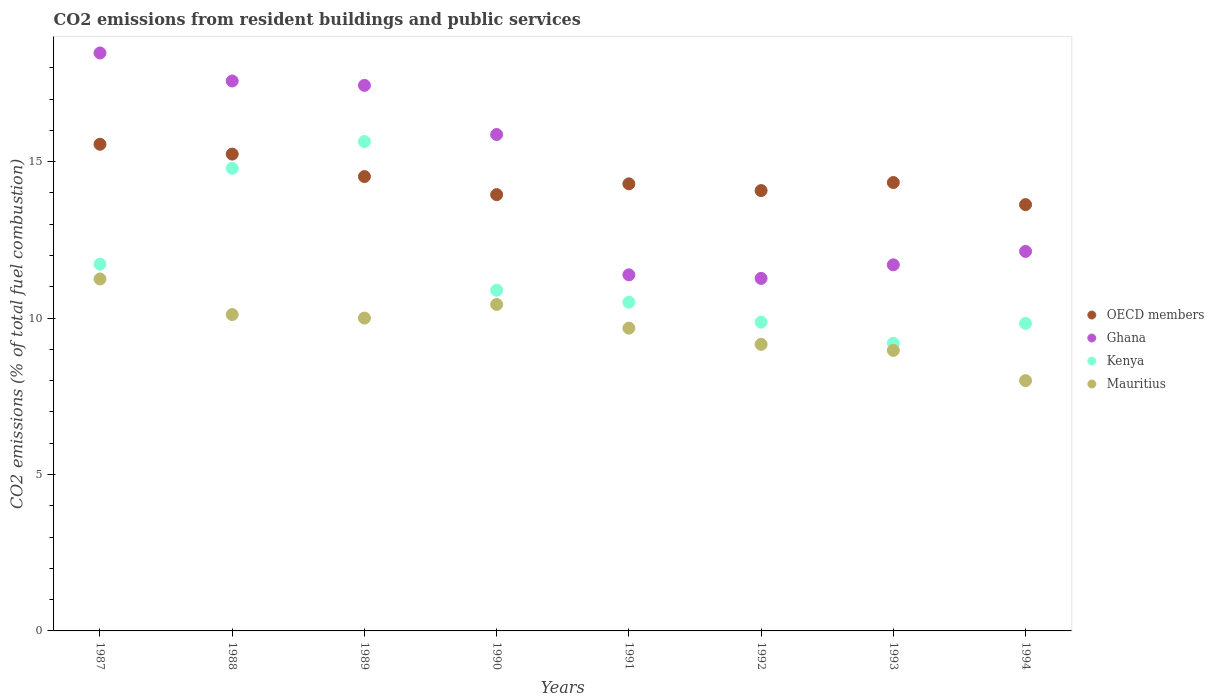How many different coloured dotlines are there?
Give a very brief answer. 4. What is the total CO2 emitted in Ghana in 1988?
Provide a succinct answer. 17.58. Across all years, what is the maximum total CO2 emitted in Mauritius?
Offer a very short reply. 11.25. Across all years, what is the minimum total CO2 emitted in Ghana?
Keep it short and to the point. 11.27. In which year was the total CO2 emitted in Ghana minimum?
Your response must be concise. 1992. What is the total total CO2 emitted in Kenya in the graph?
Offer a very short reply. 92.44. What is the difference between the total CO2 emitted in Mauritius in 1988 and that in 1990?
Your response must be concise. -0.32. What is the difference between the total CO2 emitted in OECD members in 1993 and the total CO2 emitted in Ghana in 1989?
Ensure brevity in your answer.  -3.11. What is the average total CO2 emitted in Ghana per year?
Provide a short and direct response. 14.48. In the year 1992, what is the difference between the total CO2 emitted in Kenya and total CO2 emitted in OECD members?
Provide a succinct answer. -4.21. In how many years, is the total CO2 emitted in Ghana greater than 2?
Ensure brevity in your answer.  8. What is the ratio of the total CO2 emitted in Ghana in 1987 to that in 1991?
Offer a very short reply. 1.62. Is the total CO2 emitted in Mauritius in 1989 less than that in 1992?
Your answer should be compact. No. What is the difference between the highest and the second highest total CO2 emitted in Mauritius?
Give a very brief answer. 0.82. What is the difference between the highest and the lowest total CO2 emitted in Mauritius?
Your answer should be compact. 3.25. Is the sum of the total CO2 emitted in Kenya in 1992 and 1994 greater than the maximum total CO2 emitted in Ghana across all years?
Provide a succinct answer. Yes. Is it the case that in every year, the sum of the total CO2 emitted in Kenya and total CO2 emitted in Ghana  is greater than the sum of total CO2 emitted in Mauritius and total CO2 emitted in OECD members?
Provide a short and direct response. No. Does the total CO2 emitted in OECD members monotonically increase over the years?
Provide a short and direct response. No. Is the total CO2 emitted in Kenya strictly greater than the total CO2 emitted in Mauritius over the years?
Offer a terse response. Yes. How many dotlines are there?
Your response must be concise. 4. How many years are there in the graph?
Your response must be concise. 8. Does the graph contain any zero values?
Ensure brevity in your answer.  No. Where does the legend appear in the graph?
Your answer should be very brief. Center right. How many legend labels are there?
Provide a succinct answer. 4. How are the legend labels stacked?
Provide a succinct answer. Vertical. What is the title of the graph?
Provide a short and direct response. CO2 emissions from resident buildings and public services. What is the label or title of the X-axis?
Provide a short and direct response. Years. What is the label or title of the Y-axis?
Ensure brevity in your answer.  CO2 emissions (% of total fuel combustion). What is the CO2 emissions (% of total fuel combustion) of OECD members in 1987?
Provide a short and direct response. 15.56. What is the CO2 emissions (% of total fuel combustion) in Ghana in 1987?
Offer a very short reply. 18.47. What is the CO2 emissions (% of total fuel combustion) in Kenya in 1987?
Provide a succinct answer. 11.72. What is the CO2 emissions (% of total fuel combustion) of Mauritius in 1987?
Keep it short and to the point. 11.25. What is the CO2 emissions (% of total fuel combustion) of OECD members in 1988?
Ensure brevity in your answer.  15.24. What is the CO2 emissions (% of total fuel combustion) of Ghana in 1988?
Make the answer very short. 17.58. What is the CO2 emissions (% of total fuel combustion) of Kenya in 1988?
Keep it short and to the point. 14.79. What is the CO2 emissions (% of total fuel combustion) of Mauritius in 1988?
Your answer should be compact. 10.11. What is the CO2 emissions (% of total fuel combustion) in OECD members in 1989?
Offer a very short reply. 14.52. What is the CO2 emissions (% of total fuel combustion) in Ghana in 1989?
Your response must be concise. 17.44. What is the CO2 emissions (% of total fuel combustion) of Kenya in 1989?
Your answer should be very brief. 15.64. What is the CO2 emissions (% of total fuel combustion) in OECD members in 1990?
Offer a terse response. 13.95. What is the CO2 emissions (% of total fuel combustion) of Ghana in 1990?
Ensure brevity in your answer.  15.87. What is the CO2 emissions (% of total fuel combustion) of Kenya in 1990?
Offer a very short reply. 10.89. What is the CO2 emissions (% of total fuel combustion) in Mauritius in 1990?
Your answer should be compact. 10.43. What is the CO2 emissions (% of total fuel combustion) in OECD members in 1991?
Keep it short and to the point. 14.29. What is the CO2 emissions (% of total fuel combustion) in Ghana in 1991?
Provide a succinct answer. 11.38. What is the CO2 emissions (% of total fuel combustion) in Kenya in 1991?
Your answer should be compact. 10.51. What is the CO2 emissions (% of total fuel combustion) of Mauritius in 1991?
Your answer should be very brief. 9.68. What is the CO2 emissions (% of total fuel combustion) of OECD members in 1992?
Give a very brief answer. 14.07. What is the CO2 emissions (% of total fuel combustion) of Ghana in 1992?
Your answer should be compact. 11.27. What is the CO2 emissions (% of total fuel combustion) of Kenya in 1992?
Give a very brief answer. 9.87. What is the CO2 emissions (% of total fuel combustion) in Mauritius in 1992?
Keep it short and to the point. 9.16. What is the CO2 emissions (% of total fuel combustion) of OECD members in 1993?
Your answer should be compact. 14.33. What is the CO2 emissions (% of total fuel combustion) in Ghana in 1993?
Provide a short and direct response. 11.7. What is the CO2 emissions (% of total fuel combustion) in Kenya in 1993?
Make the answer very short. 9.19. What is the CO2 emissions (% of total fuel combustion) in Mauritius in 1993?
Make the answer very short. 8.97. What is the CO2 emissions (% of total fuel combustion) of OECD members in 1994?
Your answer should be compact. 13.63. What is the CO2 emissions (% of total fuel combustion) in Ghana in 1994?
Your answer should be very brief. 12.13. What is the CO2 emissions (% of total fuel combustion) in Kenya in 1994?
Give a very brief answer. 9.83. What is the CO2 emissions (% of total fuel combustion) of Mauritius in 1994?
Your answer should be compact. 8. Across all years, what is the maximum CO2 emissions (% of total fuel combustion) of OECD members?
Give a very brief answer. 15.56. Across all years, what is the maximum CO2 emissions (% of total fuel combustion) in Ghana?
Your answer should be compact. 18.47. Across all years, what is the maximum CO2 emissions (% of total fuel combustion) in Kenya?
Your response must be concise. 15.64. Across all years, what is the maximum CO2 emissions (% of total fuel combustion) of Mauritius?
Your answer should be compact. 11.25. Across all years, what is the minimum CO2 emissions (% of total fuel combustion) of OECD members?
Provide a succinct answer. 13.63. Across all years, what is the minimum CO2 emissions (% of total fuel combustion) in Ghana?
Make the answer very short. 11.27. Across all years, what is the minimum CO2 emissions (% of total fuel combustion) in Kenya?
Give a very brief answer. 9.19. What is the total CO2 emissions (% of total fuel combustion) of OECD members in the graph?
Give a very brief answer. 115.59. What is the total CO2 emissions (% of total fuel combustion) in Ghana in the graph?
Your response must be concise. 115.84. What is the total CO2 emissions (% of total fuel combustion) of Kenya in the graph?
Provide a succinct answer. 92.44. What is the total CO2 emissions (% of total fuel combustion) of Mauritius in the graph?
Your response must be concise. 77.6. What is the difference between the CO2 emissions (% of total fuel combustion) of OECD members in 1987 and that in 1988?
Ensure brevity in your answer.  0.31. What is the difference between the CO2 emissions (% of total fuel combustion) in Ghana in 1987 and that in 1988?
Your answer should be very brief. 0.9. What is the difference between the CO2 emissions (% of total fuel combustion) in Kenya in 1987 and that in 1988?
Offer a terse response. -3.07. What is the difference between the CO2 emissions (% of total fuel combustion) in Mauritius in 1987 and that in 1988?
Make the answer very short. 1.14. What is the difference between the CO2 emissions (% of total fuel combustion) in OECD members in 1987 and that in 1989?
Give a very brief answer. 1.03. What is the difference between the CO2 emissions (% of total fuel combustion) of Ghana in 1987 and that in 1989?
Offer a very short reply. 1.04. What is the difference between the CO2 emissions (% of total fuel combustion) in Kenya in 1987 and that in 1989?
Give a very brief answer. -3.92. What is the difference between the CO2 emissions (% of total fuel combustion) in OECD members in 1987 and that in 1990?
Offer a very short reply. 1.61. What is the difference between the CO2 emissions (% of total fuel combustion) in Ghana in 1987 and that in 1990?
Provide a succinct answer. 2.61. What is the difference between the CO2 emissions (% of total fuel combustion) in Kenya in 1987 and that in 1990?
Provide a succinct answer. 0.83. What is the difference between the CO2 emissions (% of total fuel combustion) in Mauritius in 1987 and that in 1990?
Offer a terse response. 0.82. What is the difference between the CO2 emissions (% of total fuel combustion) of OECD members in 1987 and that in 1991?
Give a very brief answer. 1.26. What is the difference between the CO2 emissions (% of total fuel combustion) of Ghana in 1987 and that in 1991?
Your answer should be very brief. 7.09. What is the difference between the CO2 emissions (% of total fuel combustion) in Kenya in 1987 and that in 1991?
Offer a terse response. 1.22. What is the difference between the CO2 emissions (% of total fuel combustion) of Mauritius in 1987 and that in 1991?
Your answer should be compact. 1.57. What is the difference between the CO2 emissions (% of total fuel combustion) of OECD members in 1987 and that in 1992?
Offer a terse response. 1.48. What is the difference between the CO2 emissions (% of total fuel combustion) in Ghana in 1987 and that in 1992?
Give a very brief answer. 7.21. What is the difference between the CO2 emissions (% of total fuel combustion) of Kenya in 1987 and that in 1992?
Ensure brevity in your answer.  1.85. What is the difference between the CO2 emissions (% of total fuel combustion) in Mauritius in 1987 and that in 1992?
Offer a terse response. 2.09. What is the difference between the CO2 emissions (% of total fuel combustion) in OECD members in 1987 and that in 1993?
Provide a succinct answer. 1.22. What is the difference between the CO2 emissions (% of total fuel combustion) of Ghana in 1987 and that in 1993?
Give a very brief answer. 6.77. What is the difference between the CO2 emissions (% of total fuel combustion) of Kenya in 1987 and that in 1993?
Offer a terse response. 2.53. What is the difference between the CO2 emissions (% of total fuel combustion) of Mauritius in 1987 and that in 1993?
Make the answer very short. 2.28. What is the difference between the CO2 emissions (% of total fuel combustion) of OECD members in 1987 and that in 1994?
Offer a very short reply. 1.93. What is the difference between the CO2 emissions (% of total fuel combustion) in Ghana in 1987 and that in 1994?
Your answer should be compact. 6.34. What is the difference between the CO2 emissions (% of total fuel combustion) of Kenya in 1987 and that in 1994?
Ensure brevity in your answer.  1.89. What is the difference between the CO2 emissions (% of total fuel combustion) of Mauritius in 1987 and that in 1994?
Keep it short and to the point. 3.25. What is the difference between the CO2 emissions (% of total fuel combustion) of OECD members in 1988 and that in 1989?
Your answer should be very brief. 0.72. What is the difference between the CO2 emissions (% of total fuel combustion) in Ghana in 1988 and that in 1989?
Give a very brief answer. 0.14. What is the difference between the CO2 emissions (% of total fuel combustion) in Kenya in 1988 and that in 1989?
Your response must be concise. -0.85. What is the difference between the CO2 emissions (% of total fuel combustion) in Mauritius in 1988 and that in 1989?
Offer a very short reply. 0.11. What is the difference between the CO2 emissions (% of total fuel combustion) in OECD members in 1988 and that in 1990?
Give a very brief answer. 1.3. What is the difference between the CO2 emissions (% of total fuel combustion) in Ghana in 1988 and that in 1990?
Ensure brevity in your answer.  1.71. What is the difference between the CO2 emissions (% of total fuel combustion) of Kenya in 1988 and that in 1990?
Provide a short and direct response. 3.9. What is the difference between the CO2 emissions (% of total fuel combustion) in Mauritius in 1988 and that in 1990?
Your response must be concise. -0.32. What is the difference between the CO2 emissions (% of total fuel combustion) of OECD members in 1988 and that in 1991?
Your answer should be compact. 0.95. What is the difference between the CO2 emissions (% of total fuel combustion) in Ghana in 1988 and that in 1991?
Ensure brevity in your answer.  6.2. What is the difference between the CO2 emissions (% of total fuel combustion) in Kenya in 1988 and that in 1991?
Your response must be concise. 4.28. What is the difference between the CO2 emissions (% of total fuel combustion) in Mauritius in 1988 and that in 1991?
Offer a terse response. 0.43. What is the difference between the CO2 emissions (% of total fuel combustion) of OECD members in 1988 and that in 1992?
Give a very brief answer. 1.17. What is the difference between the CO2 emissions (% of total fuel combustion) in Ghana in 1988 and that in 1992?
Offer a very short reply. 6.31. What is the difference between the CO2 emissions (% of total fuel combustion) of Kenya in 1988 and that in 1992?
Make the answer very short. 4.92. What is the difference between the CO2 emissions (% of total fuel combustion) in Mauritius in 1988 and that in 1992?
Ensure brevity in your answer.  0.95. What is the difference between the CO2 emissions (% of total fuel combustion) in OECD members in 1988 and that in 1993?
Provide a short and direct response. 0.91. What is the difference between the CO2 emissions (% of total fuel combustion) in Ghana in 1988 and that in 1993?
Offer a terse response. 5.88. What is the difference between the CO2 emissions (% of total fuel combustion) of Kenya in 1988 and that in 1993?
Give a very brief answer. 5.59. What is the difference between the CO2 emissions (% of total fuel combustion) of Mauritius in 1988 and that in 1993?
Your answer should be very brief. 1.15. What is the difference between the CO2 emissions (% of total fuel combustion) of OECD members in 1988 and that in 1994?
Your answer should be compact. 1.62. What is the difference between the CO2 emissions (% of total fuel combustion) of Ghana in 1988 and that in 1994?
Keep it short and to the point. 5.45. What is the difference between the CO2 emissions (% of total fuel combustion) of Kenya in 1988 and that in 1994?
Your response must be concise. 4.96. What is the difference between the CO2 emissions (% of total fuel combustion) of Mauritius in 1988 and that in 1994?
Ensure brevity in your answer.  2.11. What is the difference between the CO2 emissions (% of total fuel combustion) in OECD members in 1989 and that in 1990?
Your response must be concise. 0.58. What is the difference between the CO2 emissions (% of total fuel combustion) in Ghana in 1989 and that in 1990?
Your answer should be compact. 1.57. What is the difference between the CO2 emissions (% of total fuel combustion) in Kenya in 1989 and that in 1990?
Keep it short and to the point. 4.75. What is the difference between the CO2 emissions (% of total fuel combustion) in Mauritius in 1989 and that in 1990?
Keep it short and to the point. -0.43. What is the difference between the CO2 emissions (% of total fuel combustion) of OECD members in 1989 and that in 1991?
Offer a very short reply. 0.23. What is the difference between the CO2 emissions (% of total fuel combustion) in Ghana in 1989 and that in 1991?
Offer a terse response. 6.06. What is the difference between the CO2 emissions (% of total fuel combustion) in Kenya in 1989 and that in 1991?
Ensure brevity in your answer.  5.13. What is the difference between the CO2 emissions (% of total fuel combustion) of Mauritius in 1989 and that in 1991?
Provide a short and direct response. 0.32. What is the difference between the CO2 emissions (% of total fuel combustion) in OECD members in 1989 and that in 1992?
Provide a short and direct response. 0.45. What is the difference between the CO2 emissions (% of total fuel combustion) in Ghana in 1989 and that in 1992?
Make the answer very short. 6.17. What is the difference between the CO2 emissions (% of total fuel combustion) of Kenya in 1989 and that in 1992?
Give a very brief answer. 5.77. What is the difference between the CO2 emissions (% of total fuel combustion) in Mauritius in 1989 and that in 1992?
Ensure brevity in your answer.  0.84. What is the difference between the CO2 emissions (% of total fuel combustion) in OECD members in 1989 and that in 1993?
Offer a terse response. 0.19. What is the difference between the CO2 emissions (% of total fuel combustion) in Ghana in 1989 and that in 1993?
Provide a succinct answer. 5.74. What is the difference between the CO2 emissions (% of total fuel combustion) of Kenya in 1989 and that in 1993?
Your answer should be compact. 6.45. What is the difference between the CO2 emissions (% of total fuel combustion) in Mauritius in 1989 and that in 1993?
Ensure brevity in your answer.  1.03. What is the difference between the CO2 emissions (% of total fuel combustion) of OECD members in 1989 and that in 1994?
Ensure brevity in your answer.  0.9. What is the difference between the CO2 emissions (% of total fuel combustion) in Ghana in 1989 and that in 1994?
Your response must be concise. 5.31. What is the difference between the CO2 emissions (% of total fuel combustion) in Kenya in 1989 and that in 1994?
Provide a short and direct response. 5.81. What is the difference between the CO2 emissions (% of total fuel combustion) in OECD members in 1990 and that in 1991?
Your answer should be compact. -0.35. What is the difference between the CO2 emissions (% of total fuel combustion) of Ghana in 1990 and that in 1991?
Your answer should be compact. 4.49. What is the difference between the CO2 emissions (% of total fuel combustion) in Kenya in 1990 and that in 1991?
Make the answer very short. 0.38. What is the difference between the CO2 emissions (% of total fuel combustion) of Mauritius in 1990 and that in 1991?
Ensure brevity in your answer.  0.76. What is the difference between the CO2 emissions (% of total fuel combustion) in OECD members in 1990 and that in 1992?
Provide a short and direct response. -0.13. What is the difference between the CO2 emissions (% of total fuel combustion) of Ghana in 1990 and that in 1992?
Offer a terse response. 4.6. What is the difference between the CO2 emissions (% of total fuel combustion) in Kenya in 1990 and that in 1992?
Offer a terse response. 1.02. What is the difference between the CO2 emissions (% of total fuel combustion) of Mauritius in 1990 and that in 1992?
Provide a short and direct response. 1.27. What is the difference between the CO2 emissions (% of total fuel combustion) in OECD members in 1990 and that in 1993?
Keep it short and to the point. -0.39. What is the difference between the CO2 emissions (% of total fuel combustion) of Ghana in 1990 and that in 1993?
Make the answer very short. 4.17. What is the difference between the CO2 emissions (% of total fuel combustion) of Kenya in 1990 and that in 1993?
Ensure brevity in your answer.  1.7. What is the difference between the CO2 emissions (% of total fuel combustion) of Mauritius in 1990 and that in 1993?
Ensure brevity in your answer.  1.47. What is the difference between the CO2 emissions (% of total fuel combustion) in OECD members in 1990 and that in 1994?
Make the answer very short. 0.32. What is the difference between the CO2 emissions (% of total fuel combustion) in Ghana in 1990 and that in 1994?
Provide a short and direct response. 3.74. What is the difference between the CO2 emissions (% of total fuel combustion) of Kenya in 1990 and that in 1994?
Keep it short and to the point. 1.06. What is the difference between the CO2 emissions (% of total fuel combustion) in Mauritius in 1990 and that in 1994?
Your answer should be compact. 2.43. What is the difference between the CO2 emissions (% of total fuel combustion) of OECD members in 1991 and that in 1992?
Ensure brevity in your answer.  0.22. What is the difference between the CO2 emissions (% of total fuel combustion) in Ghana in 1991 and that in 1992?
Offer a very short reply. 0.11. What is the difference between the CO2 emissions (% of total fuel combustion) in Kenya in 1991 and that in 1992?
Provide a short and direct response. 0.64. What is the difference between the CO2 emissions (% of total fuel combustion) of Mauritius in 1991 and that in 1992?
Keep it short and to the point. 0.52. What is the difference between the CO2 emissions (% of total fuel combustion) of OECD members in 1991 and that in 1993?
Offer a terse response. -0.04. What is the difference between the CO2 emissions (% of total fuel combustion) in Ghana in 1991 and that in 1993?
Offer a very short reply. -0.32. What is the difference between the CO2 emissions (% of total fuel combustion) of Kenya in 1991 and that in 1993?
Provide a short and direct response. 1.31. What is the difference between the CO2 emissions (% of total fuel combustion) in Mauritius in 1991 and that in 1993?
Make the answer very short. 0.71. What is the difference between the CO2 emissions (% of total fuel combustion) in OECD members in 1991 and that in 1994?
Keep it short and to the point. 0.66. What is the difference between the CO2 emissions (% of total fuel combustion) of Ghana in 1991 and that in 1994?
Ensure brevity in your answer.  -0.75. What is the difference between the CO2 emissions (% of total fuel combustion) in Kenya in 1991 and that in 1994?
Make the answer very short. 0.68. What is the difference between the CO2 emissions (% of total fuel combustion) of Mauritius in 1991 and that in 1994?
Offer a terse response. 1.68. What is the difference between the CO2 emissions (% of total fuel combustion) in OECD members in 1992 and that in 1993?
Your answer should be very brief. -0.26. What is the difference between the CO2 emissions (% of total fuel combustion) in Ghana in 1992 and that in 1993?
Ensure brevity in your answer.  -0.43. What is the difference between the CO2 emissions (% of total fuel combustion) of Kenya in 1992 and that in 1993?
Provide a short and direct response. 0.68. What is the difference between the CO2 emissions (% of total fuel combustion) of Mauritius in 1992 and that in 1993?
Offer a very short reply. 0.19. What is the difference between the CO2 emissions (% of total fuel combustion) in OECD members in 1992 and that in 1994?
Your response must be concise. 0.45. What is the difference between the CO2 emissions (% of total fuel combustion) of Ghana in 1992 and that in 1994?
Offer a terse response. -0.86. What is the difference between the CO2 emissions (% of total fuel combustion) of Kenya in 1992 and that in 1994?
Provide a short and direct response. 0.04. What is the difference between the CO2 emissions (% of total fuel combustion) in Mauritius in 1992 and that in 1994?
Your response must be concise. 1.16. What is the difference between the CO2 emissions (% of total fuel combustion) of OECD members in 1993 and that in 1994?
Your response must be concise. 0.71. What is the difference between the CO2 emissions (% of total fuel combustion) of Ghana in 1993 and that in 1994?
Your answer should be very brief. -0.43. What is the difference between the CO2 emissions (% of total fuel combustion) of Kenya in 1993 and that in 1994?
Your answer should be very brief. -0.64. What is the difference between the CO2 emissions (% of total fuel combustion) of Mauritius in 1993 and that in 1994?
Offer a terse response. 0.97. What is the difference between the CO2 emissions (% of total fuel combustion) of OECD members in 1987 and the CO2 emissions (% of total fuel combustion) of Ghana in 1988?
Keep it short and to the point. -2.02. What is the difference between the CO2 emissions (% of total fuel combustion) of OECD members in 1987 and the CO2 emissions (% of total fuel combustion) of Kenya in 1988?
Make the answer very short. 0.77. What is the difference between the CO2 emissions (% of total fuel combustion) in OECD members in 1987 and the CO2 emissions (% of total fuel combustion) in Mauritius in 1988?
Provide a short and direct response. 5.44. What is the difference between the CO2 emissions (% of total fuel combustion) in Ghana in 1987 and the CO2 emissions (% of total fuel combustion) in Kenya in 1988?
Provide a succinct answer. 3.69. What is the difference between the CO2 emissions (% of total fuel combustion) of Ghana in 1987 and the CO2 emissions (% of total fuel combustion) of Mauritius in 1988?
Keep it short and to the point. 8.36. What is the difference between the CO2 emissions (% of total fuel combustion) in Kenya in 1987 and the CO2 emissions (% of total fuel combustion) in Mauritius in 1988?
Offer a terse response. 1.61. What is the difference between the CO2 emissions (% of total fuel combustion) in OECD members in 1987 and the CO2 emissions (% of total fuel combustion) in Ghana in 1989?
Make the answer very short. -1.88. What is the difference between the CO2 emissions (% of total fuel combustion) of OECD members in 1987 and the CO2 emissions (% of total fuel combustion) of Kenya in 1989?
Keep it short and to the point. -0.09. What is the difference between the CO2 emissions (% of total fuel combustion) of OECD members in 1987 and the CO2 emissions (% of total fuel combustion) of Mauritius in 1989?
Provide a succinct answer. 5.56. What is the difference between the CO2 emissions (% of total fuel combustion) in Ghana in 1987 and the CO2 emissions (% of total fuel combustion) in Kenya in 1989?
Keep it short and to the point. 2.83. What is the difference between the CO2 emissions (% of total fuel combustion) of Ghana in 1987 and the CO2 emissions (% of total fuel combustion) of Mauritius in 1989?
Your answer should be very brief. 8.47. What is the difference between the CO2 emissions (% of total fuel combustion) of Kenya in 1987 and the CO2 emissions (% of total fuel combustion) of Mauritius in 1989?
Offer a very short reply. 1.72. What is the difference between the CO2 emissions (% of total fuel combustion) in OECD members in 1987 and the CO2 emissions (% of total fuel combustion) in Ghana in 1990?
Give a very brief answer. -0.31. What is the difference between the CO2 emissions (% of total fuel combustion) in OECD members in 1987 and the CO2 emissions (% of total fuel combustion) in Kenya in 1990?
Give a very brief answer. 4.67. What is the difference between the CO2 emissions (% of total fuel combustion) in OECD members in 1987 and the CO2 emissions (% of total fuel combustion) in Mauritius in 1990?
Give a very brief answer. 5.12. What is the difference between the CO2 emissions (% of total fuel combustion) of Ghana in 1987 and the CO2 emissions (% of total fuel combustion) of Kenya in 1990?
Give a very brief answer. 7.58. What is the difference between the CO2 emissions (% of total fuel combustion) in Ghana in 1987 and the CO2 emissions (% of total fuel combustion) in Mauritius in 1990?
Make the answer very short. 8.04. What is the difference between the CO2 emissions (% of total fuel combustion) of Kenya in 1987 and the CO2 emissions (% of total fuel combustion) of Mauritius in 1990?
Your response must be concise. 1.29. What is the difference between the CO2 emissions (% of total fuel combustion) of OECD members in 1987 and the CO2 emissions (% of total fuel combustion) of Ghana in 1991?
Offer a terse response. 4.17. What is the difference between the CO2 emissions (% of total fuel combustion) of OECD members in 1987 and the CO2 emissions (% of total fuel combustion) of Kenya in 1991?
Your response must be concise. 5.05. What is the difference between the CO2 emissions (% of total fuel combustion) of OECD members in 1987 and the CO2 emissions (% of total fuel combustion) of Mauritius in 1991?
Ensure brevity in your answer.  5.88. What is the difference between the CO2 emissions (% of total fuel combustion) in Ghana in 1987 and the CO2 emissions (% of total fuel combustion) in Kenya in 1991?
Your answer should be compact. 7.97. What is the difference between the CO2 emissions (% of total fuel combustion) of Ghana in 1987 and the CO2 emissions (% of total fuel combustion) of Mauritius in 1991?
Make the answer very short. 8.8. What is the difference between the CO2 emissions (% of total fuel combustion) in Kenya in 1987 and the CO2 emissions (% of total fuel combustion) in Mauritius in 1991?
Ensure brevity in your answer.  2.04. What is the difference between the CO2 emissions (% of total fuel combustion) in OECD members in 1987 and the CO2 emissions (% of total fuel combustion) in Ghana in 1992?
Give a very brief answer. 4.29. What is the difference between the CO2 emissions (% of total fuel combustion) in OECD members in 1987 and the CO2 emissions (% of total fuel combustion) in Kenya in 1992?
Offer a very short reply. 5.69. What is the difference between the CO2 emissions (% of total fuel combustion) of OECD members in 1987 and the CO2 emissions (% of total fuel combustion) of Mauritius in 1992?
Offer a terse response. 6.4. What is the difference between the CO2 emissions (% of total fuel combustion) of Ghana in 1987 and the CO2 emissions (% of total fuel combustion) of Kenya in 1992?
Give a very brief answer. 8.6. What is the difference between the CO2 emissions (% of total fuel combustion) in Ghana in 1987 and the CO2 emissions (% of total fuel combustion) in Mauritius in 1992?
Your answer should be very brief. 9.31. What is the difference between the CO2 emissions (% of total fuel combustion) in Kenya in 1987 and the CO2 emissions (% of total fuel combustion) in Mauritius in 1992?
Your response must be concise. 2.56. What is the difference between the CO2 emissions (% of total fuel combustion) of OECD members in 1987 and the CO2 emissions (% of total fuel combustion) of Ghana in 1993?
Offer a terse response. 3.85. What is the difference between the CO2 emissions (% of total fuel combustion) of OECD members in 1987 and the CO2 emissions (% of total fuel combustion) of Kenya in 1993?
Your response must be concise. 6.36. What is the difference between the CO2 emissions (% of total fuel combustion) of OECD members in 1987 and the CO2 emissions (% of total fuel combustion) of Mauritius in 1993?
Make the answer very short. 6.59. What is the difference between the CO2 emissions (% of total fuel combustion) of Ghana in 1987 and the CO2 emissions (% of total fuel combustion) of Kenya in 1993?
Give a very brief answer. 9.28. What is the difference between the CO2 emissions (% of total fuel combustion) in Ghana in 1987 and the CO2 emissions (% of total fuel combustion) in Mauritius in 1993?
Ensure brevity in your answer.  9.51. What is the difference between the CO2 emissions (% of total fuel combustion) of Kenya in 1987 and the CO2 emissions (% of total fuel combustion) of Mauritius in 1993?
Your answer should be compact. 2.76. What is the difference between the CO2 emissions (% of total fuel combustion) of OECD members in 1987 and the CO2 emissions (% of total fuel combustion) of Ghana in 1994?
Keep it short and to the point. 3.42. What is the difference between the CO2 emissions (% of total fuel combustion) in OECD members in 1987 and the CO2 emissions (% of total fuel combustion) in Kenya in 1994?
Ensure brevity in your answer.  5.73. What is the difference between the CO2 emissions (% of total fuel combustion) of OECD members in 1987 and the CO2 emissions (% of total fuel combustion) of Mauritius in 1994?
Keep it short and to the point. 7.56. What is the difference between the CO2 emissions (% of total fuel combustion) of Ghana in 1987 and the CO2 emissions (% of total fuel combustion) of Kenya in 1994?
Your answer should be very brief. 8.64. What is the difference between the CO2 emissions (% of total fuel combustion) in Ghana in 1987 and the CO2 emissions (% of total fuel combustion) in Mauritius in 1994?
Keep it short and to the point. 10.47. What is the difference between the CO2 emissions (% of total fuel combustion) of Kenya in 1987 and the CO2 emissions (% of total fuel combustion) of Mauritius in 1994?
Make the answer very short. 3.72. What is the difference between the CO2 emissions (% of total fuel combustion) in OECD members in 1988 and the CO2 emissions (% of total fuel combustion) in Ghana in 1989?
Provide a succinct answer. -2.2. What is the difference between the CO2 emissions (% of total fuel combustion) of OECD members in 1988 and the CO2 emissions (% of total fuel combustion) of Kenya in 1989?
Your answer should be compact. -0.4. What is the difference between the CO2 emissions (% of total fuel combustion) of OECD members in 1988 and the CO2 emissions (% of total fuel combustion) of Mauritius in 1989?
Keep it short and to the point. 5.24. What is the difference between the CO2 emissions (% of total fuel combustion) in Ghana in 1988 and the CO2 emissions (% of total fuel combustion) in Kenya in 1989?
Make the answer very short. 1.94. What is the difference between the CO2 emissions (% of total fuel combustion) of Ghana in 1988 and the CO2 emissions (% of total fuel combustion) of Mauritius in 1989?
Give a very brief answer. 7.58. What is the difference between the CO2 emissions (% of total fuel combustion) of Kenya in 1988 and the CO2 emissions (% of total fuel combustion) of Mauritius in 1989?
Offer a very short reply. 4.79. What is the difference between the CO2 emissions (% of total fuel combustion) of OECD members in 1988 and the CO2 emissions (% of total fuel combustion) of Ghana in 1990?
Make the answer very short. -0.63. What is the difference between the CO2 emissions (% of total fuel combustion) of OECD members in 1988 and the CO2 emissions (% of total fuel combustion) of Kenya in 1990?
Your answer should be compact. 4.35. What is the difference between the CO2 emissions (% of total fuel combustion) of OECD members in 1988 and the CO2 emissions (% of total fuel combustion) of Mauritius in 1990?
Provide a short and direct response. 4.81. What is the difference between the CO2 emissions (% of total fuel combustion) of Ghana in 1988 and the CO2 emissions (% of total fuel combustion) of Kenya in 1990?
Your response must be concise. 6.69. What is the difference between the CO2 emissions (% of total fuel combustion) of Ghana in 1988 and the CO2 emissions (% of total fuel combustion) of Mauritius in 1990?
Provide a succinct answer. 7.14. What is the difference between the CO2 emissions (% of total fuel combustion) of Kenya in 1988 and the CO2 emissions (% of total fuel combustion) of Mauritius in 1990?
Your answer should be compact. 4.35. What is the difference between the CO2 emissions (% of total fuel combustion) of OECD members in 1988 and the CO2 emissions (% of total fuel combustion) of Ghana in 1991?
Ensure brevity in your answer.  3.86. What is the difference between the CO2 emissions (% of total fuel combustion) of OECD members in 1988 and the CO2 emissions (% of total fuel combustion) of Kenya in 1991?
Keep it short and to the point. 4.74. What is the difference between the CO2 emissions (% of total fuel combustion) of OECD members in 1988 and the CO2 emissions (% of total fuel combustion) of Mauritius in 1991?
Ensure brevity in your answer.  5.56. What is the difference between the CO2 emissions (% of total fuel combustion) in Ghana in 1988 and the CO2 emissions (% of total fuel combustion) in Kenya in 1991?
Provide a short and direct response. 7.07. What is the difference between the CO2 emissions (% of total fuel combustion) of Ghana in 1988 and the CO2 emissions (% of total fuel combustion) of Mauritius in 1991?
Provide a short and direct response. 7.9. What is the difference between the CO2 emissions (% of total fuel combustion) in Kenya in 1988 and the CO2 emissions (% of total fuel combustion) in Mauritius in 1991?
Offer a terse response. 5.11. What is the difference between the CO2 emissions (% of total fuel combustion) in OECD members in 1988 and the CO2 emissions (% of total fuel combustion) in Ghana in 1992?
Ensure brevity in your answer.  3.97. What is the difference between the CO2 emissions (% of total fuel combustion) of OECD members in 1988 and the CO2 emissions (% of total fuel combustion) of Kenya in 1992?
Provide a succinct answer. 5.37. What is the difference between the CO2 emissions (% of total fuel combustion) of OECD members in 1988 and the CO2 emissions (% of total fuel combustion) of Mauritius in 1992?
Your response must be concise. 6.08. What is the difference between the CO2 emissions (% of total fuel combustion) of Ghana in 1988 and the CO2 emissions (% of total fuel combustion) of Kenya in 1992?
Ensure brevity in your answer.  7.71. What is the difference between the CO2 emissions (% of total fuel combustion) in Ghana in 1988 and the CO2 emissions (% of total fuel combustion) in Mauritius in 1992?
Offer a terse response. 8.42. What is the difference between the CO2 emissions (% of total fuel combustion) in Kenya in 1988 and the CO2 emissions (% of total fuel combustion) in Mauritius in 1992?
Give a very brief answer. 5.63. What is the difference between the CO2 emissions (% of total fuel combustion) of OECD members in 1988 and the CO2 emissions (% of total fuel combustion) of Ghana in 1993?
Your answer should be very brief. 3.54. What is the difference between the CO2 emissions (% of total fuel combustion) of OECD members in 1988 and the CO2 emissions (% of total fuel combustion) of Kenya in 1993?
Give a very brief answer. 6.05. What is the difference between the CO2 emissions (% of total fuel combustion) of OECD members in 1988 and the CO2 emissions (% of total fuel combustion) of Mauritius in 1993?
Offer a very short reply. 6.28. What is the difference between the CO2 emissions (% of total fuel combustion) in Ghana in 1988 and the CO2 emissions (% of total fuel combustion) in Kenya in 1993?
Make the answer very short. 8.38. What is the difference between the CO2 emissions (% of total fuel combustion) of Ghana in 1988 and the CO2 emissions (% of total fuel combustion) of Mauritius in 1993?
Make the answer very short. 8.61. What is the difference between the CO2 emissions (% of total fuel combustion) in Kenya in 1988 and the CO2 emissions (% of total fuel combustion) in Mauritius in 1993?
Your answer should be compact. 5.82. What is the difference between the CO2 emissions (% of total fuel combustion) in OECD members in 1988 and the CO2 emissions (% of total fuel combustion) in Ghana in 1994?
Provide a succinct answer. 3.11. What is the difference between the CO2 emissions (% of total fuel combustion) in OECD members in 1988 and the CO2 emissions (% of total fuel combustion) in Kenya in 1994?
Your answer should be compact. 5.41. What is the difference between the CO2 emissions (% of total fuel combustion) in OECD members in 1988 and the CO2 emissions (% of total fuel combustion) in Mauritius in 1994?
Keep it short and to the point. 7.24. What is the difference between the CO2 emissions (% of total fuel combustion) of Ghana in 1988 and the CO2 emissions (% of total fuel combustion) of Kenya in 1994?
Your answer should be very brief. 7.75. What is the difference between the CO2 emissions (% of total fuel combustion) of Ghana in 1988 and the CO2 emissions (% of total fuel combustion) of Mauritius in 1994?
Your response must be concise. 9.58. What is the difference between the CO2 emissions (% of total fuel combustion) in Kenya in 1988 and the CO2 emissions (% of total fuel combustion) in Mauritius in 1994?
Keep it short and to the point. 6.79. What is the difference between the CO2 emissions (% of total fuel combustion) of OECD members in 1989 and the CO2 emissions (% of total fuel combustion) of Ghana in 1990?
Offer a terse response. -1.34. What is the difference between the CO2 emissions (% of total fuel combustion) in OECD members in 1989 and the CO2 emissions (% of total fuel combustion) in Kenya in 1990?
Your response must be concise. 3.63. What is the difference between the CO2 emissions (% of total fuel combustion) in OECD members in 1989 and the CO2 emissions (% of total fuel combustion) in Mauritius in 1990?
Offer a very short reply. 4.09. What is the difference between the CO2 emissions (% of total fuel combustion) of Ghana in 1989 and the CO2 emissions (% of total fuel combustion) of Kenya in 1990?
Provide a short and direct response. 6.55. What is the difference between the CO2 emissions (% of total fuel combustion) of Ghana in 1989 and the CO2 emissions (% of total fuel combustion) of Mauritius in 1990?
Make the answer very short. 7. What is the difference between the CO2 emissions (% of total fuel combustion) in Kenya in 1989 and the CO2 emissions (% of total fuel combustion) in Mauritius in 1990?
Your response must be concise. 5.21. What is the difference between the CO2 emissions (% of total fuel combustion) in OECD members in 1989 and the CO2 emissions (% of total fuel combustion) in Ghana in 1991?
Offer a very short reply. 3.14. What is the difference between the CO2 emissions (% of total fuel combustion) of OECD members in 1989 and the CO2 emissions (% of total fuel combustion) of Kenya in 1991?
Your answer should be very brief. 4.02. What is the difference between the CO2 emissions (% of total fuel combustion) in OECD members in 1989 and the CO2 emissions (% of total fuel combustion) in Mauritius in 1991?
Ensure brevity in your answer.  4.85. What is the difference between the CO2 emissions (% of total fuel combustion) in Ghana in 1989 and the CO2 emissions (% of total fuel combustion) in Kenya in 1991?
Your answer should be very brief. 6.93. What is the difference between the CO2 emissions (% of total fuel combustion) in Ghana in 1989 and the CO2 emissions (% of total fuel combustion) in Mauritius in 1991?
Your answer should be very brief. 7.76. What is the difference between the CO2 emissions (% of total fuel combustion) in Kenya in 1989 and the CO2 emissions (% of total fuel combustion) in Mauritius in 1991?
Provide a succinct answer. 5.96. What is the difference between the CO2 emissions (% of total fuel combustion) in OECD members in 1989 and the CO2 emissions (% of total fuel combustion) in Ghana in 1992?
Give a very brief answer. 3.26. What is the difference between the CO2 emissions (% of total fuel combustion) in OECD members in 1989 and the CO2 emissions (% of total fuel combustion) in Kenya in 1992?
Provide a succinct answer. 4.65. What is the difference between the CO2 emissions (% of total fuel combustion) of OECD members in 1989 and the CO2 emissions (% of total fuel combustion) of Mauritius in 1992?
Offer a terse response. 5.36. What is the difference between the CO2 emissions (% of total fuel combustion) in Ghana in 1989 and the CO2 emissions (% of total fuel combustion) in Kenya in 1992?
Keep it short and to the point. 7.57. What is the difference between the CO2 emissions (% of total fuel combustion) in Ghana in 1989 and the CO2 emissions (% of total fuel combustion) in Mauritius in 1992?
Offer a terse response. 8.28. What is the difference between the CO2 emissions (% of total fuel combustion) of Kenya in 1989 and the CO2 emissions (% of total fuel combustion) of Mauritius in 1992?
Your answer should be very brief. 6.48. What is the difference between the CO2 emissions (% of total fuel combustion) in OECD members in 1989 and the CO2 emissions (% of total fuel combustion) in Ghana in 1993?
Make the answer very short. 2.82. What is the difference between the CO2 emissions (% of total fuel combustion) of OECD members in 1989 and the CO2 emissions (% of total fuel combustion) of Kenya in 1993?
Ensure brevity in your answer.  5.33. What is the difference between the CO2 emissions (% of total fuel combustion) in OECD members in 1989 and the CO2 emissions (% of total fuel combustion) in Mauritius in 1993?
Ensure brevity in your answer.  5.56. What is the difference between the CO2 emissions (% of total fuel combustion) of Ghana in 1989 and the CO2 emissions (% of total fuel combustion) of Kenya in 1993?
Provide a short and direct response. 8.24. What is the difference between the CO2 emissions (% of total fuel combustion) of Ghana in 1989 and the CO2 emissions (% of total fuel combustion) of Mauritius in 1993?
Your response must be concise. 8.47. What is the difference between the CO2 emissions (% of total fuel combustion) in Kenya in 1989 and the CO2 emissions (% of total fuel combustion) in Mauritius in 1993?
Keep it short and to the point. 6.68. What is the difference between the CO2 emissions (% of total fuel combustion) in OECD members in 1989 and the CO2 emissions (% of total fuel combustion) in Ghana in 1994?
Offer a terse response. 2.39. What is the difference between the CO2 emissions (% of total fuel combustion) in OECD members in 1989 and the CO2 emissions (% of total fuel combustion) in Kenya in 1994?
Keep it short and to the point. 4.69. What is the difference between the CO2 emissions (% of total fuel combustion) in OECD members in 1989 and the CO2 emissions (% of total fuel combustion) in Mauritius in 1994?
Provide a succinct answer. 6.52. What is the difference between the CO2 emissions (% of total fuel combustion) of Ghana in 1989 and the CO2 emissions (% of total fuel combustion) of Kenya in 1994?
Ensure brevity in your answer.  7.61. What is the difference between the CO2 emissions (% of total fuel combustion) in Ghana in 1989 and the CO2 emissions (% of total fuel combustion) in Mauritius in 1994?
Your answer should be compact. 9.44. What is the difference between the CO2 emissions (% of total fuel combustion) of Kenya in 1989 and the CO2 emissions (% of total fuel combustion) of Mauritius in 1994?
Offer a terse response. 7.64. What is the difference between the CO2 emissions (% of total fuel combustion) in OECD members in 1990 and the CO2 emissions (% of total fuel combustion) in Ghana in 1991?
Your answer should be very brief. 2.56. What is the difference between the CO2 emissions (% of total fuel combustion) of OECD members in 1990 and the CO2 emissions (% of total fuel combustion) of Kenya in 1991?
Offer a very short reply. 3.44. What is the difference between the CO2 emissions (% of total fuel combustion) in OECD members in 1990 and the CO2 emissions (% of total fuel combustion) in Mauritius in 1991?
Give a very brief answer. 4.27. What is the difference between the CO2 emissions (% of total fuel combustion) in Ghana in 1990 and the CO2 emissions (% of total fuel combustion) in Kenya in 1991?
Make the answer very short. 5.36. What is the difference between the CO2 emissions (% of total fuel combustion) in Ghana in 1990 and the CO2 emissions (% of total fuel combustion) in Mauritius in 1991?
Make the answer very short. 6.19. What is the difference between the CO2 emissions (% of total fuel combustion) of Kenya in 1990 and the CO2 emissions (% of total fuel combustion) of Mauritius in 1991?
Provide a short and direct response. 1.21. What is the difference between the CO2 emissions (% of total fuel combustion) in OECD members in 1990 and the CO2 emissions (% of total fuel combustion) in Ghana in 1992?
Your answer should be very brief. 2.68. What is the difference between the CO2 emissions (% of total fuel combustion) of OECD members in 1990 and the CO2 emissions (% of total fuel combustion) of Kenya in 1992?
Provide a succinct answer. 4.08. What is the difference between the CO2 emissions (% of total fuel combustion) in OECD members in 1990 and the CO2 emissions (% of total fuel combustion) in Mauritius in 1992?
Provide a short and direct response. 4.79. What is the difference between the CO2 emissions (% of total fuel combustion) of Ghana in 1990 and the CO2 emissions (% of total fuel combustion) of Kenya in 1992?
Provide a succinct answer. 6. What is the difference between the CO2 emissions (% of total fuel combustion) of Ghana in 1990 and the CO2 emissions (% of total fuel combustion) of Mauritius in 1992?
Offer a terse response. 6.71. What is the difference between the CO2 emissions (% of total fuel combustion) of Kenya in 1990 and the CO2 emissions (% of total fuel combustion) of Mauritius in 1992?
Your answer should be compact. 1.73. What is the difference between the CO2 emissions (% of total fuel combustion) of OECD members in 1990 and the CO2 emissions (% of total fuel combustion) of Ghana in 1993?
Offer a very short reply. 2.24. What is the difference between the CO2 emissions (% of total fuel combustion) in OECD members in 1990 and the CO2 emissions (% of total fuel combustion) in Kenya in 1993?
Provide a succinct answer. 4.75. What is the difference between the CO2 emissions (% of total fuel combustion) of OECD members in 1990 and the CO2 emissions (% of total fuel combustion) of Mauritius in 1993?
Your answer should be compact. 4.98. What is the difference between the CO2 emissions (% of total fuel combustion) of Ghana in 1990 and the CO2 emissions (% of total fuel combustion) of Kenya in 1993?
Your answer should be compact. 6.67. What is the difference between the CO2 emissions (% of total fuel combustion) in Ghana in 1990 and the CO2 emissions (% of total fuel combustion) in Mauritius in 1993?
Make the answer very short. 6.9. What is the difference between the CO2 emissions (% of total fuel combustion) of Kenya in 1990 and the CO2 emissions (% of total fuel combustion) of Mauritius in 1993?
Provide a succinct answer. 1.92. What is the difference between the CO2 emissions (% of total fuel combustion) in OECD members in 1990 and the CO2 emissions (% of total fuel combustion) in Ghana in 1994?
Ensure brevity in your answer.  1.81. What is the difference between the CO2 emissions (% of total fuel combustion) in OECD members in 1990 and the CO2 emissions (% of total fuel combustion) in Kenya in 1994?
Make the answer very short. 4.12. What is the difference between the CO2 emissions (% of total fuel combustion) of OECD members in 1990 and the CO2 emissions (% of total fuel combustion) of Mauritius in 1994?
Provide a short and direct response. 5.95. What is the difference between the CO2 emissions (% of total fuel combustion) of Ghana in 1990 and the CO2 emissions (% of total fuel combustion) of Kenya in 1994?
Provide a short and direct response. 6.04. What is the difference between the CO2 emissions (% of total fuel combustion) in Ghana in 1990 and the CO2 emissions (% of total fuel combustion) in Mauritius in 1994?
Offer a terse response. 7.87. What is the difference between the CO2 emissions (% of total fuel combustion) of Kenya in 1990 and the CO2 emissions (% of total fuel combustion) of Mauritius in 1994?
Offer a terse response. 2.89. What is the difference between the CO2 emissions (% of total fuel combustion) in OECD members in 1991 and the CO2 emissions (% of total fuel combustion) in Ghana in 1992?
Make the answer very short. 3.02. What is the difference between the CO2 emissions (% of total fuel combustion) of OECD members in 1991 and the CO2 emissions (% of total fuel combustion) of Kenya in 1992?
Offer a terse response. 4.42. What is the difference between the CO2 emissions (% of total fuel combustion) in OECD members in 1991 and the CO2 emissions (% of total fuel combustion) in Mauritius in 1992?
Offer a terse response. 5.13. What is the difference between the CO2 emissions (% of total fuel combustion) in Ghana in 1991 and the CO2 emissions (% of total fuel combustion) in Kenya in 1992?
Keep it short and to the point. 1.51. What is the difference between the CO2 emissions (% of total fuel combustion) of Ghana in 1991 and the CO2 emissions (% of total fuel combustion) of Mauritius in 1992?
Give a very brief answer. 2.22. What is the difference between the CO2 emissions (% of total fuel combustion) in Kenya in 1991 and the CO2 emissions (% of total fuel combustion) in Mauritius in 1992?
Ensure brevity in your answer.  1.35. What is the difference between the CO2 emissions (% of total fuel combustion) of OECD members in 1991 and the CO2 emissions (% of total fuel combustion) of Ghana in 1993?
Ensure brevity in your answer.  2.59. What is the difference between the CO2 emissions (% of total fuel combustion) in OECD members in 1991 and the CO2 emissions (% of total fuel combustion) in Kenya in 1993?
Provide a succinct answer. 5.1. What is the difference between the CO2 emissions (% of total fuel combustion) of OECD members in 1991 and the CO2 emissions (% of total fuel combustion) of Mauritius in 1993?
Offer a very short reply. 5.33. What is the difference between the CO2 emissions (% of total fuel combustion) in Ghana in 1991 and the CO2 emissions (% of total fuel combustion) in Kenya in 1993?
Ensure brevity in your answer.  2.19. What is the difference between the CO2 emissions (% of total fuel combustion) of Ghana in 1991 and the CO2 emissions (% of total fuel combustion) of Mauritius in 1993?
Provide a short and direct response. 2.42. What is the difference between the CO2 emissions (% of total fuel combustion) in Kenya in 1991 and the CO2 emissions (% of total fuel combustion) in Mauritius in 1993?
Ensure brevity in your answer.  1.54. What is the difference between the CO2 emissions (% of total fuel combustion) of OECD members in 1991 and the CO2 emissions (% of total fuel combustion) of Ghana in 1994?
Your answer should be compact. 2.16. What is the difference between the CO2 emissions (% of total fuel combustion) in OECD members in 1991 and the CO2 emissions (% of total fuel combustion) in Kenya in 1994?
Ensure brevity in your answer.  4.46. What is the difference between the CO2 emissions (% of total fuel combustion) in OECD members in 1991 and the CO2 emissions (% of total fuel combustion) in Mauritius in 1994?
Ensure brevity in your answer.  6.29. What is the difference between the CO2 emissions (% of total fuel combustion) in Ghana in 1991 and the CO2 emissions (% of total fuel combustion) in Kenya in 1994?
Ensure brevity in your answer.  1.55. What is the difference between the CO2 emissions (% of total fuel combustion) in Ghana in 1991 and the CO2 emissions (% of total fuel combustion) in Mauritius in 1994?
Offer a terse response. 3.38. What is the difference between the CO2 emissions (% of total fuel combustion) in Kenya in 1991 and the CO2 emissions (% of total fuel combustion) in Mauritius in 1994?
Make the answer very short. 2.51. What is the difference between the CO2 emissions (% of total fuel combustion) in OECD members in 1992 and the CO2 emissions (% of total fuel combustion) in Ghana in 1993?
Give a very brief answer. 2.37. What is the difference between the CO2 emissions (% of total fuel combustion) in OECD members in 1992 and the CO2 emissions (% of total fuel combustion) in Kenya in 1993?
Your answer should be very brief. 4.88. What is the difference between the CO2 emissions (% of total fuel combustion) in OECD members in 1992 and the CO2 emissions (% of total fuel combustion) in Mauritius in 1993?
Your answer should be compact. 5.11. What is the difference between the CO2 emissions (% of total fuel combustion) in Ghana in 1992 and the CO2 emissions (% of total fuel combustion) in Kenya in 1993?
Your answer should be very brief. 2.07. What is the difference between the CO2 emissions (% of total fuel combustion) in Ghana in 1992 and the CO2 emissions (% of total fuel combustion) in Mauritius in 1993?
Make the answer very short. 2.3. What is the difference between the CO2 emissions (% of total fuel combustion) in Kenya in 1992 and the CO2 emissions (% of total fuel combustion) in Mauritius in 1993?
Provide a succinct answer. 0.9. What is the difference between the CO2 emissions (% of total fuel combustion) in OECD members in 1992 and the CO2 emissions (% of total fuel combustion) in Ghana in 1994?
Your answer should be compact. 1.94. What is the difference between the CO2 emissions (% of total fuel combustion) in OECD members in 1992 and the CO2 emissions (% of total fuel combustion) in Kenya in 1994?
Your answer should be very brief. 4.24. What is the difference between the CO2 emissions (% of total fuel combustion) in OECD members in 1992 and the CO2 emissions (% of total fuel combustion) in Mauritius in 1994?
Keep it short and to the point. 6.07. What is the difference between the CO2 emissions (% of total fuel combustion) in Ghana in 1992 and the CO2 emissions (% of total fuel combustion) in Kenya in 1994?
Offer a very short reply. 1.44. What is the difference between the CO2 emissions (% of total fuel combustion) in Ghana in 1992 and the CO2 emissions (% of total fuel combustion) in Mauritius in 1994?
Your answer should be very brief. 3.27. What is the difference between the CO2 emissions (% of total fuel combustion) of Kenya in 1992 and the CO2 emissions (% of total fuel combustion) of Mauritius in 1994?
Your answer should be very brief. 1.87. What is the difference between the CO2 emissions (% of total fuel combustion) of OECD members in 1993 and the CO2 emissions (% of total fuel combustion) of Ghana in 1994?
Your response must be concise. 2.2. What is the difference between the CO2 emissions (% of total fuel combustion) in OECD members in 1993 and the CO2 emissions (% of total fuel combustion) in Kenya in 1994?
Your answer should be compact. 4.5. What is the difference between the CO2 emissions (% of total fuel combustion) of OECD members in 1993 and the CO2 emissions (% of total fuel combustion) of Mauritius in 1994?
Offer a terse response. 6.33. What is the difference between the CO2 emissions (% of total fuel combustion) in Ghana in 1993 and the CO2 emissions (% of total fuel combustion) in Kenya in 1994?
Your answer should be compact. 1.87. What is the difference between the CO2 emissions (% of total fuel combustion) in Ghana in 1993 and the CO2 emissions (% of total fuel combustion) in Mauritius in 1994?
Your response must be concise. 3.7. What is the difference between the CO2 emissions (% of total fuel combustion) of Kenya in 1993 and the CO2 emissions (% of total fuel combustion) of Mauritius in 1994?
Your response must be concise. 1.19. What is the average CO2 emissions (% of total fuel combustion) in OECD members per year?
Offer a very short reply. 14.45. What is the average CO2 emissions (% of total fuel combustion) in Ghana per year?
Your response must be concise. 14.48. What is the average CO2 emissions (% of total fuel combustion) of Kenya per year?
Ensure brevity in your answer.  11.55. In the year 1987, what is the difference between the CO2 emissions (% of total fuel combustion) of OECD members and CO2 emissions (% of total fuel combustion) of Ghana?
Give a very brief answer. -2.92. In the year 1987, what is the difference between the CO2 emissions (% of total fuel combustion) of OECD members and CO2 emissions (% of total fuel combustion) of Kenya?
Your answer should be compact. 3.83. In the year 1987, what is the difference between the CO2 emissions (% of total fuel combustion) of OECD members and CO2 emissions (% of total fuel combustion) of Mauritius?
Provide a short and direct response. 4.31. In the year 1987, what is the difference between the CO2 emissions (% of total fuel combustion) in Ghana and CO2 emissions (% of total fuel combustion) in Kenya?
Your answer should be compact. 6.75. In the year 1987, what is the difference between the CO2 emissions (% of total fuel combustion) in Ghana and CO2 emissions (% of total fuel combustion) in Mauritius?
Ensure brevity in your answer.  7.22. In the year 1987, what is the difference between the CO2 emissions (% of total fuel combustion) of Kenya and CO2 emissions (% of total fuel combustion) of Mauritius?
Offer a very short reply. 0.47. In the year 1988, what is the difference between the CO2 emissions (% of total fuel combustion) in OECD members and CO2 emissions (% of total fuel combustion) in Ghana?
Give a very brief answer. -2.34. In the year 1988, what is the difference between the CO2 emissions (% of total fuel combustion) in OECD members and CO2 emissions (% of total fuel combustion) in Kenya?
Provide a short and direct response. 0.45. In the year 1988, what is the difference between the CO2 emissions (% of total fuel combustion) of OECD members and CO2 emissions (% of total fuel combustion) of Mauritius?
Ensure brevity in your answer.  5.13. In the year 1988, what is the difference between the CO2 emissions (% of total fuel combustion) in Ghana and CO2 emissions (% of total fuel combustion) in Kenya?
Provide a short and direct response. 2.79. In the year 1988, what is the difference between the CO2 emissions (% of total fuel combustion) in Ghana and CO2 emissions (% of total fuel combustion) in Mauritius?
Ensure brevity in your answer.  7.47. In the year 1988, what is the difference between the CO2 emissions (% of total fuel combustion) in Kenya and CO2 emissions (% of total fuel combustion) in Mauritius?
Provide a succinct answer. 4.68. In the year 1989, what is the difference between the CO2 emissions (% of total fuel combustion) in OECD members and CO2 emissions (% of total fuel combustion) in Ghana?
Give a very brief answer. -2.91. In the year 1989, what is the difference between the CO2 emissions (% of total fuel combustion) in OECD members and CO2 emissions (% of total fuel combustion) in Kenya?
Give a very brief answer. -1.12. In the year 1989, what is the difference between the CO2 emissions (% of total fuel combustion) of OECD members and CO2 emissions (% of total fuel combustion) of Mauritius?
Your answer should be compact. 4.52. In the year 1989, what is the difference between the CO2 emissions (% of total fuel combustion) in Ghana and CO2 emissions (% of total fuel combustion) in Kenya?
Provide a short and direct response. 1.8. In the year 1989, what is the difference between the CO2 emissions (% of total fuel combustion) of Ghana and CO2 emissions (% of total fuel combustion) of Mauritius?
Your answer should be very brief. 7.44. In the year 1989, what is the difference between the CO2 emissions (% of total fuel combustion) of Kenya and CO2 emissions (% of total fuel combustion) of Mauritius?
Give a very brief answer. 5.64. In the year 1990, what is the difference between the CO2 emissions (% of total fuel combustion) in OECD members and CO2 emissions (% of total fuel combustion) in Ghana?
Offer a very short reply. -1.92. In the year 1990, what is the difference between the CO2 emissions (% of total fuel combustion) of OECD members and CO2 emissions (% of total fuel combustion) of Kenya?
Offer a very short reply. 3.06. In the year 1990, what is the difference between the CO2 emissions (% of total fuel combustion) in OECD members and CO2 emissions (% of total fuel combustion) in Mauritius?
Ensure brevity in your answer.  3.51. In the year 1990, what is the difference between the CO2 emissions (% of total fuel combustion) in Ghana and CO2 emissions (% of total fuel combustion) in Kenya?
Give a very brief answer. 4.98. In the year 1990, what is the difference between the CO2 emissions (% of total fuel combustion) of Ghana and CO2 emissions (% of total fuel combustion) of Mauritius?
Your answer should be very brief. 5.43. In the year 1990, what is the difference between the CO2 emissions (% of total fuel combustion) of Kenya and CO2 emissions (% of total fuel combustion) of Mauritius?
Offer a terse response. 0.45. In the year 1991, what is the difference between the CO2 emissions (% of total fuel combustion) of OECD members and CO2 emissions (% of total fuel combustion) of Ghana?
Make the answer very short. 2.91. In the year 1991, what is the difference between the CO2 emissions (% of total fuel combustion) in OECD members and CO2 emissions (% of total fuel combustion) in Kenya?
Ensure brevity in your answer.  3.78. In the year 1991, what is the difference between the CO2 emissions (% of total fuel combustion) in OECD members and CO2 emissions (% of total fuel combustion) in Mauritius?
Make the answer very short. 4.61. In the year 1991, what is the difference between the CO2 emissions (% of total fuel combustion) in Ghana and CO2 emissions (% of total fuel combustion) in Kenya?
Offer a terse response. 0.88. In the year 1991, what is the difference between the CO2 emissions (% of total fuel combustion) of Ghana and CO2 emissions (% of total fuel combustion) of Mauritius?
Your answer should be compact. 1.7. In the year 1991, what is the difference between the CO2 emissions (% of total fuel combustion) in Kenya and CO2 emissions (% of total fuel combustion) in Mauritius?
Give a very brief answer. 0.83. In the year 1992, what is the difference between the CO2 emissions (% of total fuel combustion) of OECD members and CO2 emissions (% of total fuel combustion) of Ghana?
Keep it short and to the point. 2.81. In the year 1992, what is the difference between the CO2 emissions (% of total fuel combustion) of OECD members and CO2 emissions (% of total fuel combustion) of Kenya?
Offer a very short reply. 4.21. In the year 1992, what is the difference between the CO2 emissions (% of total fuel combustion) of OECD members and CO2 emissions (% of total fuel combustion) of Mauritius?
Keep it short and to the point. 4.91. In the year 1992, what is the difference between the CO2 emissions (% of total fuel combustion) in Ghana and CO2 emissions (% of total fuel combustion) in Kenya?
Provide a short and direct response. 1.4. In the year 1992, what is the difference between the CO2 emissions (% of total fuel combustion) in Ghana and CO2 emissions (% of total fuel combustion) in Mauritius?
Make the answer very short. 2.11. In the year 1992, what is the difference between the CO2 emissions (% of total fuel combustion) in Kenya and CO2 emissions (% of total fuel combustion) in Mauritius?
Make the answer very short. 0.71. In the year 1993, what is the difference between the CO2 emissions (% of total fuel combustion) in OECD members and CO2 emissions (% of total fuel combustion) in Ghana?
Offer a terse response. 2.63. In the year 1993, what is the difference between the CO2 emissions (% of total fuel combustion) of OECD members and CO2 emissions (% of total fuel combustion) of Kenya?
Offer a very short reply. 5.14. In the year 1993, what is the difference between the CO2 emissions (% of total fuel combustion) in OECD members and CO2 emissions (% of total fuel combustion) in Mauritius?
Your answer should be compact. 5.37. In the year 1993, what is the difference between the CO2 emissions (% of total fuel combustion) in Ghana and CO2 emissions (% of total fuel combustion) in Kenya?
Give a very brief answer. 2.51. In the year 1993, what is the difference between the CO2 emissions (% of total fuel combustion) of Ghana and CO2 emissions (% of total fuel combustion) of Mauritius?
Make the answer very short. 2.74. In the year 1993, what is the difference between the CO2 emissions (% of total fuel combustion) in Kenya and CO2 emissions (% of total fuel combustion) in Mauritius?
Keep it short and to the point. 0.23. In the year 1994, what is the difference between the CO2 emissions (% of total fuel combustion) in OECD members and CO2 emissions (% of total fuel combustion) in Ghana?
Make the answer very short. 1.49. In the year 1994, what is the difference between the CO2 emissions (% of total fuel combustion) of OECD members and CO2 emissions (% of total fuel combustion) of Kenya?
Offer a very short reply. 3.8. In the year 1994, what is the difference between the CO2 emissions (% of total fuel combustion) of OECD members and CO2 emissions (% of total fuel combustion) of Mauritius?
Your response must be concise. 5.63. In the year 1994, what is the difference between the CO2 emissions (% of total fuel combustion) of Ghana and CO2 emissions (% of total fuel combustion) of Kenya?
Provide a succinct answer. 2.3. In the year 1994, what is the difference between the CO2 emissions (% of total fuel combustion) in Ghana and CO2 emissions (% of total fuel combustion) in Mauritius?
Offer a very short reply. 4.13. In the year 1994, what is the difference between the CO2 emissions (% of total fuel combustion) of Kenya and CO2 emissions (% of total fuel combustion) of Mauritius?
Provide a short and direct response. 1.83. What is the ratio of the CO2 emissions (% of total fuel combustion) in OECD members in 1987 to that in 1988?
Your answer should be very brief. 1.02. What is the ratio of the CO2 emissions (% of total fuel combustion) in Ghana in 1987 to that in 1988?
Keep it short and to the point. 1.05. What is the ratio of the CO2 emissions (% of total fuel combustion) in Kenya in 1987 to that in 1988?
Offer a terse response. 0.79. What is the ratio of the CO2 emissions (% of total fuel combustion) of Mauritius in 1987 to that in 1988?
Give a very brief answer. 1.11. What is the ratio of the CO2 emissions (% of total fuel combustion) of OECD members in 1987 to that in 1989?
Provide a short and direct response. 1.07. What is the ratio of the CO2 emissions (% of total fuel combustion) of Ghana in 1987 to that in 1989?
Keep it short and to the point. 1.06. What is the ratio of the CO2 emissions (% of total fuel combustion) of Kenya in 1987 to that in 1989?
Make the answer very short. 0.75. What is the ratio of the CO2 emissions (% of total fuel combustion) in OECD members in 1987 to that in 1990?
Ensure brevity in your answer.  1.12. What is the ratio of the CO2 emissions (% of total fuel combustion) of Ghana in 1987 to that in 1990?
Your answer should be compact. 1.16. What is the ratio of the CO2 emissions (% of total fuel combustion) in Kenya in 1987 to that in 1990?
Keep it short and to the point. 1.08. What is the ratio of the CO2 emissions (% of total fuel combustion) in Mauritius in 1987 to that in 1990?
Offer a very short reply. 1.08. What is the ratio of the CO2 emissions (% of total fuel combustion) in OECD members in 1987 to that in 1991?
Offer a terse response. 1.09. What is the ratio of the CO2 emissions (% of total fuel combustion) in Ghana in 1987 to that in 1991?
Ensure brevity in your answer.  1.62. What is the ratio of the CO2 emissions (% of total fuel combustion) in Kenya in 1987 to that in 1991?
Keep it short and to the point. 1.12. What is the ratio of the CO2 emissions (% of total fuel combustion) of Mauritius in 1987 to that in 1991?
Your answer should be compact. 1.16. What is the ratio of the CO2 emissions (% of total fuel combustion) of OECD members in 1987 to that in 1992?
Offer a terse response. 1.11. What is the ratio of the CO2 emissions (% of total fuel combustion) in Ghana in 1987 to that in 1992?
Offer a terse response. 1.64. What is the ratio of the CO2 emissions (% of total fuel combustion) of Kenya in 1987 to that in 1992?
Keep it short and to the point. 1.19. What is the ratio of the CO2 emissions (% of total fuel combustion) in Mauritius in 1987 to that in 1992?
Ensure brevity in your answer.  1.23. What is the ratio of the CO2 emissions (% of total fuel combustion) of OECD members in 1987 to that in 1993?
Provide a short and direct response. 1.09. What is the ratio of the CO2 emissions (% of total fuel combustion) in Ghana in 1987 to that in 1993?
Provide a short and direct response. 1.58. What is the ratio of the CO2 emissions (% of total fuel combustion) of Kenya in 1987 to that in 1993?
Offer a very short reply. 1.27. What is the ratio of the CO2 emissions (% of total fuel combustion) in Mauritius in 1987 to that in 1993?
Provide a succinct answer. 1.25. What is the ratio of the CO2 emissions (% of total fuel combustion) of OECD members in 1987 to that in 1994?
Your answer should be very brief. 1.14. What is the ratio of the CO2 emissions (% of total fuel combustion) in Ghana in 1987 to that in 1994?
Your answer should be compact. 1.52. What is the ratio of the CO2 emissions (% of total fuel combustion) in Kenya in 1987 to that in 1994?
Your answer should be very brief. 1.19. What is the ratio of the CO2 emissions (% of total fuel combustion) of Mauritius in 1987 to that in 1994?
Your answer should be very brief. 1.41. What is the ratio of the CO2 emissions (% of total fuel combustion) of OECD members in 1988 to that in 1989?
Offer a very short reply. 1.05. What is the ratio of the CO2 emissions (% of total fuel combustion) of Kenya in 1988 to that in 1989?
Provide a succinct answer. 0.95. What is the ratio of the CO2 emissions (% of total fuel combustion) in Mauritius in 1988 to that in 1989?
Your answer should be compact. 1.01. What is the ratio of the CO2 emissions (% of total fuel combustion) in OECD members in 1988 to that in 1990?
Provide a succinct answer. 1.09. What is the ratio of the CO2 emissions (% of total fuel combustion) in Ghana in 1988 to that in 1990?
Ensure brevity in your answer.  1.11. What is the ratio of the CO2 emissions (% of total fuel combustion) in Kenya in 1988 to that in 1990?
Make the answer very short. 1.36. What is the ratio of the CO2 emissions (% of total fuel combustion) in Mauritius in 1988 to that in 1990?
Provide a succinct answer. 0.97. What is the ratio of the CO2 emissions (% of total fuel combustion) in OECD members in 1988 to that in 1991?
Keep it short and to the point. 1.07. What is the ratio of the CO2 emissions (% of total fuel combustion) in Ghana in 1988 to that in 1991?
Offer a very short reply. 1.54. What is the ratio of the CO2 emissions (% of total fuel combustion) of Kenya in 1988 to that in 1991?
Your response must be concise. 1.41. What is the ratio of the CO2 emissions (% of total fuel combustion) in Mauritius in 1988 to that in 1991?
Your response must be concise. 1.04. What is the ratio of the CO2 emissions (% of total fuel combustion) of OECD members in 1988 to that in 1992?
Give a very brief answer. 1.08. What is the ratio of the CO2 emissions (% of total fuel combustion) in Ghana in 1988 to that in 1992?
Your answer should be compact. 1.56. What is the ratio of the CO2 emissions (% of total fuel combustion) of Kenya in 1988 to that in 1992?
Ensure brevity in your answer.  1.5. What is the ratio of the CO2 emissions (% of total fuel combustion) of Mauritius in 1988 to that in 1992?
Your response must be concise. 1.1. What is the ratio of the CO2 emissions (% of total fuel combustion) in OECD members in 1988 to that in 1993?
Give a very brief answer. 1.06. What is the ratio of the CO2 emissions (% of total fuel combustion) of Ghana in 1988 to that in 1993?
Provide a short and direct response. 1.5. What is the ratio of the CO2 emissions (% of total fuel combustion) in Kenya in 1988 to that in 1993?
Your answer should be very brief. 1.61. What is the ratio of the CO2 emissions (% of total fuel combustion) in Mauritius in 1988 to that in 1993?
Make the answer very short. 1.13. What is the ratio of the CO2 emissions (% of total fuel combustion) of OECD members in 1988 to that in 1994?
Make the answer very short. 1.12. What is the ratio of the CO2 emissions (% of total fuel combustion) in Ghana in 1988 to that in 1994?
Ensure brevity in your answer.  1.45. What is the ratio of the CO2 emissions (% of total fuel combustion) in Kenya in 1988 to that in 1994?
Keep it short and to the point. 1.5. What is the ratio of the CO2 emissions (% of total fuel combustion) in Mauritius in 1988 to that in 1994?
Your response must be concise. 1.26. What is the ratio of the CO2 emissions (% of total fuel combustion) in OECD members in 1989 to that in 1990?
Make the answer very short. 1.04. What is the ratio of the CO2 emissions (% of total fuel combustion) of Ghana in 1989 to that in 1990?
Make the answer very short. 1.1. What is the ratio of the CO2 emissions (% of total fuel combustion) in Kenya in 1989 to that in 1990?
Your answer should be very brief. 1.44. What is the ratio of the CO2 emissions (% of total fuel combustion) of OECD members in 1989 to that in 1991?
Your response must be concise. 1.02. What is the ratio of the CO2 emissions (% of total fuel combustion) of Ghana in 1989 to that in 1991?
Your answer should be very brief. 1.53. What is the ratio of the CO2 emissions (% of total fuel combustion) in Kenya in 1989 to that in 1991?
Offer a very short reply. 1.49. What is the ratio of the CO2 emissions (% of total fuel combustion) in Mauritius in 1989 to that in 1991?
Make the answer very short. 1.03. What is the ratio of the CO2 emissions (% of total fuel combustion) in OECD members in 1989 to that in 1992?
Ensure brevity in your answer.  1.03. What is the ratio of the CO2 emissions (% of total fuel combustion) of Ghana in 1989 to that in 1992?
Provide a succinct answer. 1.55. What is the ratio of the CO2 emissions (% of total fuel combustion) in Kenya in 1989 to that in 1992?
Your answer should be very brief. 1.58. What is the ratio of the CO2 emissions (% of total fuel combustion) in Mauritius in 1989 to that in 1992?
Make the answer very short. 1.09. What is the ratio of the CO2 emissions (% of total fuel combustion) of OECD members in 1989 to that in 1993?
Offer a terse response. 1.01. What is the ratio of the CO2 emissions (% of total fuel combustion) in Ghana in 1989 to that in 1993?
Provide a succinct answer. 1.49. What is the ratio of the CO2 emissions (% of total fuel combustion) of Kenya in 1989 to that in 1993?
Offer a terse response. 1.7. What is the ratio of the CO2 emissions (% of total fuel combustion) in Mauritius in 1989 to that in 1993?
Provide a short and direct response. 1.12. What is the ratio of the CO2 emissions (% of total fuel combustion) of OECD members in 1989 to that in 1994?
Your answer should be very brief. 1.07. What is the ratio of the CO2 emissions (% of total fuel combustion) of Ghana in 1989 to that in 1994?
Keep it short and to the point. 1.44. What is the ratio of the CO2 emissions (% of total fuel combustion) in Kenya in 1989 to that in 1994?
Provide a short and direct response. 1.59. What is the ratio of the CO2 emissions (% of total fuel combustion) of OECD members in 1990 to that in 1991?
Your answer should be very brief. 0.98. What is the ratio of the CO2 emissions (% of total fuel combustion) of Ghana in 1990 to that in 1991?
Your answer should be very brief. 1.39. What is the ratio of the CO2 emissions (% of total fuel combustion) of Kenya in 1990 to that in 1991?
Offer a very short reply. 1.04. What is the ratio of the CO2 emissions (% of total fuel combustion) of Mauritius in 1990 to that in 1991?
Your answer should be compact. 1.08. What is the ratio of the CO2 emissions (% of total fuel combustion) of OECD members in 1990 to that in 1992?
Your answer should be compact. 0.99. What is the ratio of the CO2 emissions (% of total fuel combustion) of Ghana in 1990 to that in 1992?
Your answer should be compact. 1.41. What is the ratio of the CO2 emissions (% of total fuel combustion) in Kenya in 1990 to that in 1992?
Make the answer very short. 1.1. What is the ratio of the CO2 emissions (% of total fuel combustion) in Mauritius in 1990 to that in 1992?
Ensure brevity in your answer.  1.14. What is the ratio of the CO2 emissions (% of total fuel combustion) of Ghana in 1990 to that in 1993?
Keep it short and to the point. 1.36. What is the ratio of the CO2 emissions (% of total fuel combustion) in Kenya in 1990 to that in 1993?
Give a very brief answer. 1.18. What is the ratio of the CO2 emissions (% of total fuel combustion) in Mauritius in 1990 to that in 1993?
Your answer should be compact. 1.16. What is the ratio of the CO2 emissions (% of total fuel combustion) of OECD members in 1990 to that in 1994?
Offer a very short reply. 1.02. What is the ratio of the CO2 emissions (% of total fuel combustion) of Ghana in 1990 to that in 1994?
Offer a very short reply. 1.31. What is the ratio of the CO2 emissions (% of total fuel combustion) in Kenya in 1990 to that in 1994?
Provide a short and direct response. 1.11. What is the ratio of the CO2 emissions (% of total fuel combustion) of Mauritius in 1990 to that in 1994?
Ensure brevity in your answer.  1.3. What is the ratio of the CO2 emissions (% of total fuel combustion) of OECD members in 1991 to that in 1992?
Provide a succinct answer. 1.02. What is the ratio of the CO2 emissions (% of total fuel combustion) in Ghana in 1991 to that in 1992?
Offer a terse response. 1.01. What is the ratio of the CO2 emissions (% of total fuel combustion) of Kenya in 1991 to that in 1992?
Make the answer very short. 1.06. What is the ratio of the CO2 emissions (% of total fuel combustion) of Mauritius in 1991 to that in 1992?
Ensure brevity in your answer.  1.06. What is the ratio of the CO2 emissions (% of total fuel combustion) in Ghana in 1991 to that in 1993?
Ensure brevity in your answer.  0.97. What is the ratio of the CO2 emissions (% of total fuel combustion) in Mauritius in 1991 to that in 1993?
Provide a succinct answer. 1.08. What is the ratio of the CO2 emissions (% of total fuel combustion) of OECD members in 1991 to that in 1994?
Ensure brevity in your answer.  1.05. What is the ratio of the CO2 emissions (% of total fuel combustion) in Ghana in 1991 to that in 1994?
Make the answer very short. 0.94. What is the ratio of the CO2 emissions (% of total fuel combustion) in Kenya in 1991 to that in 1994?
Your answer should be compact. 1.07. What is the ratio of the CO2 emissions (% of total fuel combustion) of Mauritius in 1991 to that in 1994?
Keep it short and to the point. 1.21. What is the ratio of the CO2 emissions (% of total fuel combustion) of OECD members in 1992 to that in 1993?
Your answer should be very brief. 0.98. What is the ratio of the CO2 emissions (% of total fuel combustion) in Ghana in 1992 to that in 1993?
Your response must be concise. 0.96. What is the ratio of the CO2 emissions (% of total fuel combustion) of Kenya in 1992 to that in 1993?
Make the answer very short. 1.07. What is the ratio of the CO2 emissions (% of total fuel combustion) in Mauritius in 1992 to that in 1993?
Offer a terse response. 1.02. What is the ratio of the CO2 emissions (% of total fuel combustion) in OECD members in 1992 to that in 1994?
Provide a succinct answer. 1.03. What is the ratio of the CO2 emissions (% of total fuel combustion) of Ghana in 1992 to that in 1994?
Give a very brief answer. 0.93. What is the ratio of the CO2 emissions (% of total fuel combustion) of Mauritius in 1992 to that in 1994?
Ensure brevity in your answer.  1.15. What is the ratio of the CO2 emissions (% of total fuel combustion) of OECD members in 1993 to that in 1994?
Your response must be concise. 1.05. What is the ratio of the CO2 emissions (% of total fuel combustion) of Ghana in 1993 to that in 1994?
Provide a succinct answer. 0.96. What is the ratio of the CO2 emissions (% of total fuel combustion) in Kenya in 1993 to that in 1994?
Your response must be concise. 0.94. What is the ratio of the CO2 emissions (% of total fuel combustion) of Mauritius in 1993 to that in 1994?
Ensure brevity in your answer.  1.12. What is the difference between the highest and the second highest CO2 emissions (% of total fuel combustion) of OECD members?
Provide a succinct answer. 0.31. What is the difference between the highest and the second highest CO2 emissions (% of total fuel combustion) of Ghana?
Offer a terse response. 0.9. What is the difference between the highest and the second highest CO2 emissions (% of total fuel combustion) of Kenya?
Provide a succinct answer. 0.85. What is the difference between the highest and the second highest CO2 emissions (% of total fuel combustion) in Mauritius?
Provide a succinct answer. 0.82. What is the difference between the highest and the lowest CO2 emissions (% of total fuel combustion) of OECD members?
Keep it short and to the point. 1.93. What is the difference between the highest and the lowest CO2 emissions (% of total fuel combustion) in Ghana?
Your answer should be compact. 7.21. What is the difference between the highest and the lowest CO2 emissions (% of total fuel combustion) in Kenya?
Offer a very short reply. 6.45. What is the difference between the highest and the lowest CO2 emissions (% of total fuel combustion) in Mauritius?
Ensure brevity in your answer.  3.25. 